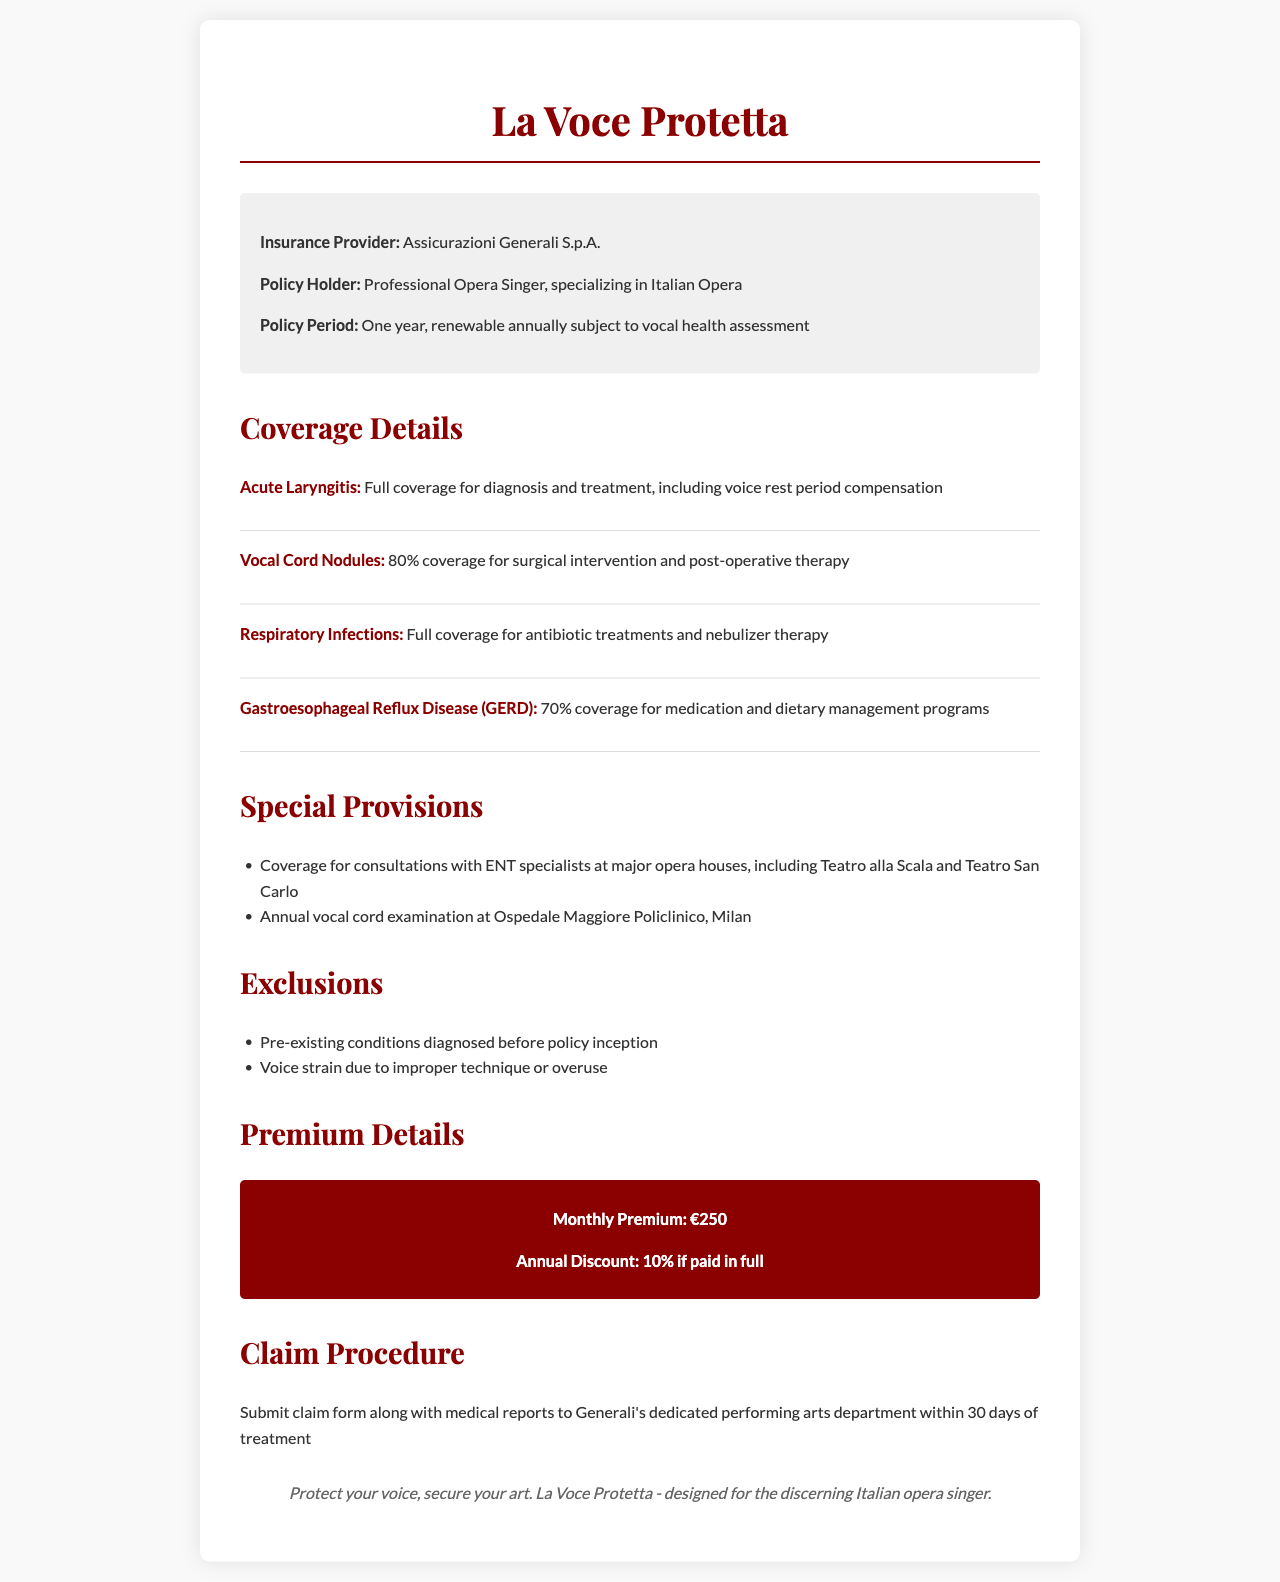What is the name of the insurance provider? The insurance provider listed in the document is Assicurazioni Generali S.p.A.
Answer: Assicurazioni Generali S.p.A What is the policy period? The policy period is stated as one year, renewable annually subject to vocal health assessment.
Answer: One year What percentage coverage is provided for Vocal Cord Nodules? The document specifies that there is 80% coverage for surgical intervention and post-operative therapy for Vocal Cord Nodules.
Answer: 80% What is the monthly premium for the policy? The document states that the monthly premium is €250.
Answer: €250 What exclusions are specified in the policy? The policy includes exclusions for pre-existing conditions diagnosed before policy inception and voice strain due to improper technique or overuse.
Answer: Pre-existing conditions; voice strain What special provision is included regarding consultations? The policy covers consultations with ENT specialists at major opera houses, including Teatro alla Scala and Teatro San Carlo.
Answer: Consultations with ENT specialists How long do you have to submit a claim? The document mentions that claims must be submitted within 30 days of treatment.
Answer: 30 days What discount is offered if the annual premium is paid in full? A 10% discount is offered if the premium is paid in full.
Answer: 10% discount 